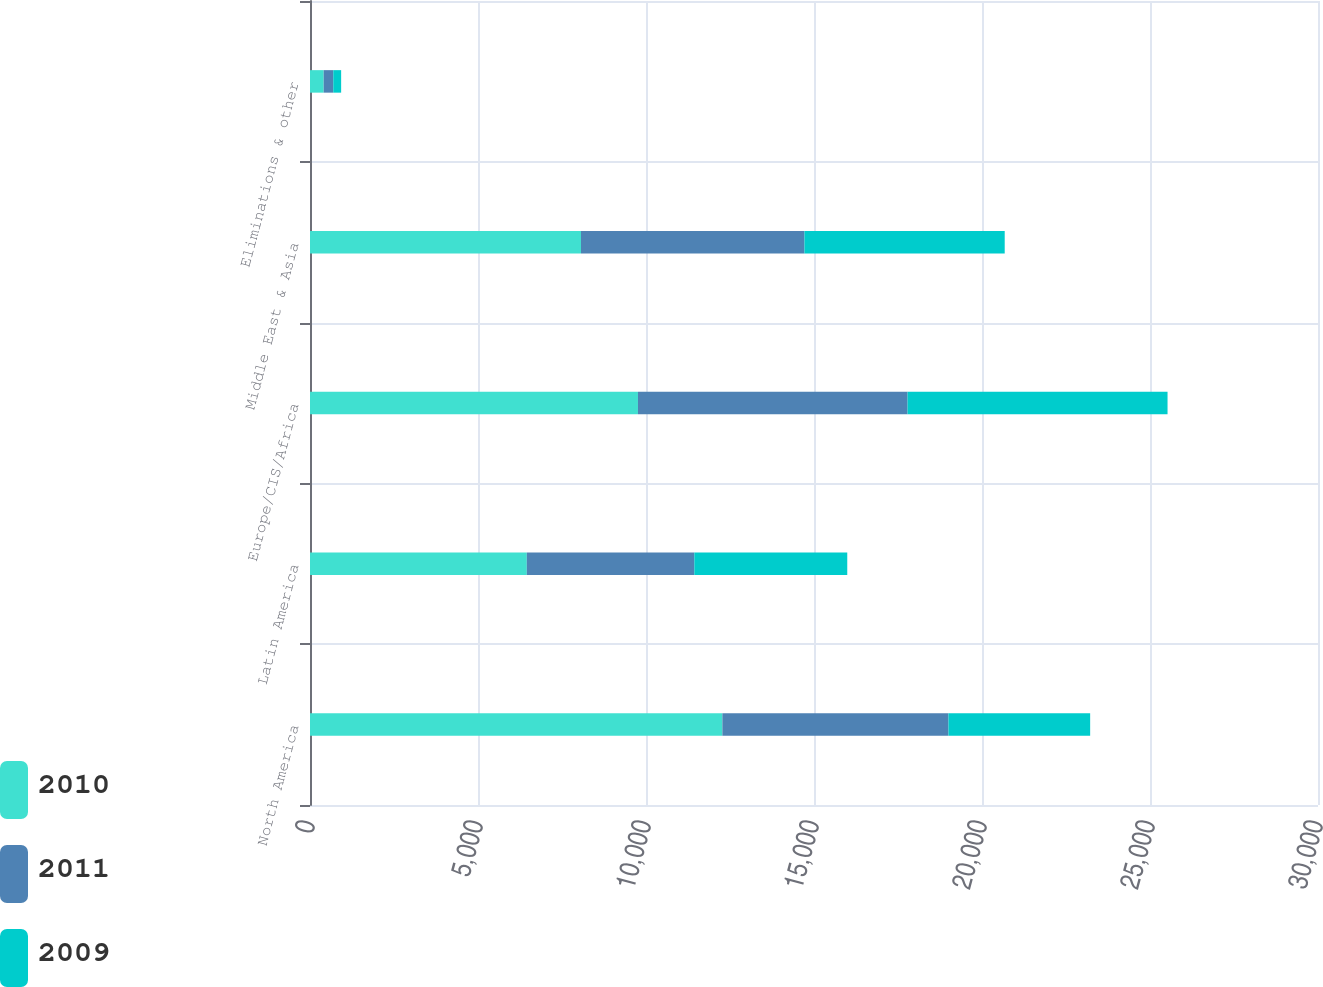<chart> <loc_0><loc_0><loc_500><loc_500><stacked_bar_chart><ecel><fcel>North America<fcel>Latin America<fcel>Europe/CIS/Africa<fcel>Middle East & Asia<fcel>Eliminations & other<nl><fcel>2010<fcel>12273<fcel>6453<fcel>9761<fcel>8065<fcel>407<nl><fcel>2011<fcel>6729<fcel>4985<fcel>8024<fcel>6650<fcel>285<nl><fcel>2009<fcel>4217<fcel>4552<fcel>7737<fcel>5961<fcel>235<nl></chart> 